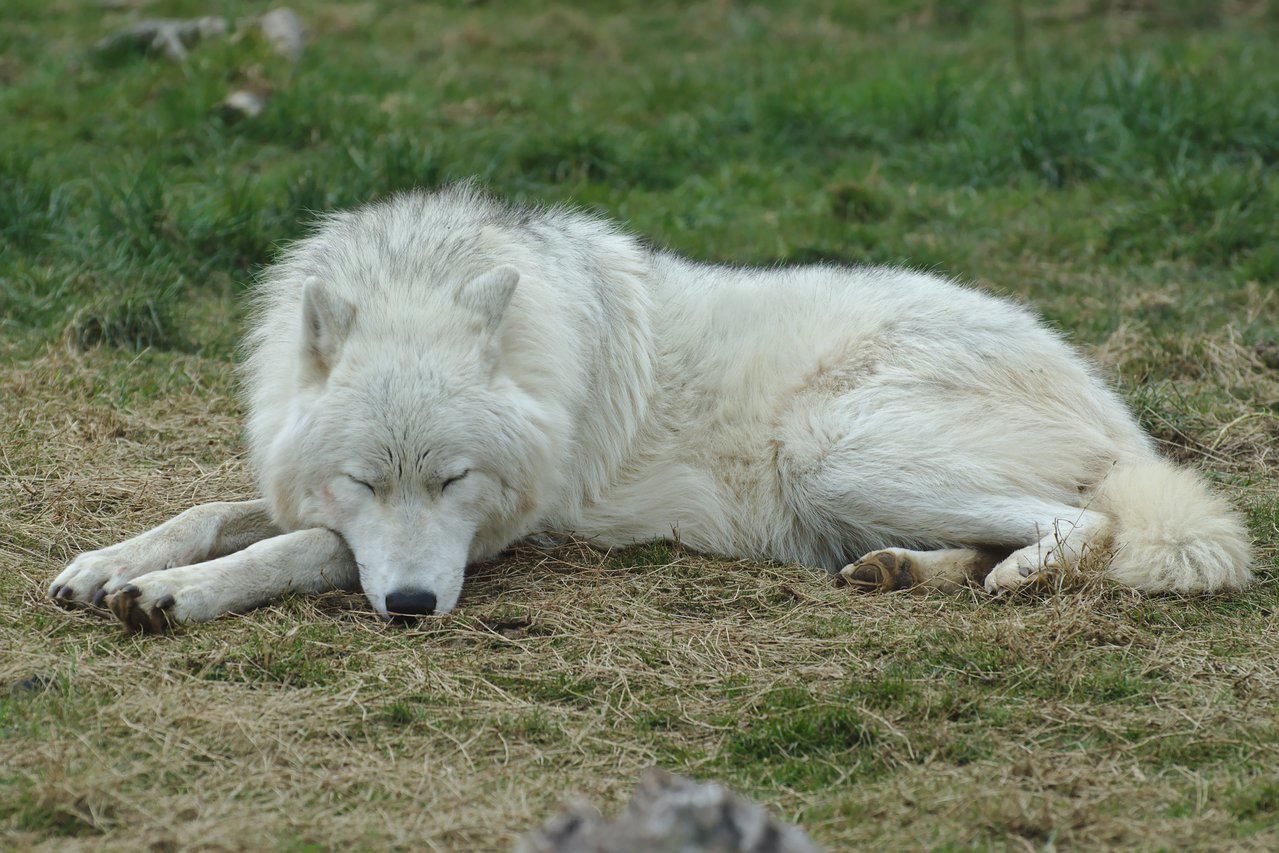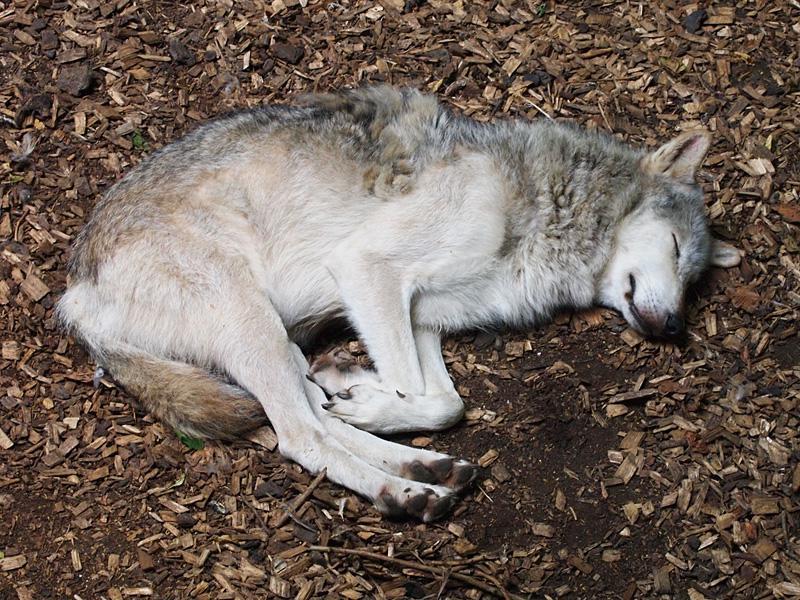The first image is the image on the left, the second image is the image on the right. Examine the images to the left and right. Is the description "One whitish wolf sleeps with its chin resting on its paws in one image." accurate? Answer yes or no. Yes. The first image is the image on the left, the second image is the image on the right. For the images displayed, is the sentence "At least one wolf is sleeping in the snow." factually correct? Answer yes or no. No. 